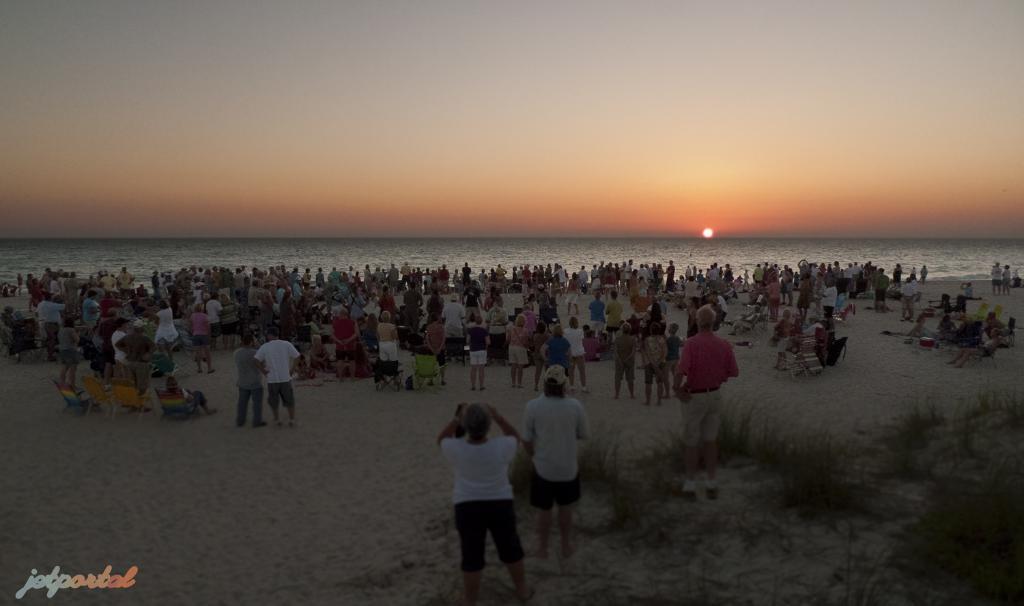Can you describe this image briefly? In this picture, we can see the beach, a few people on the ground, and we can see some objects on the ground like chairs, and we can see plants, sky, the sun, and some text in the bottom left side of the picture. 